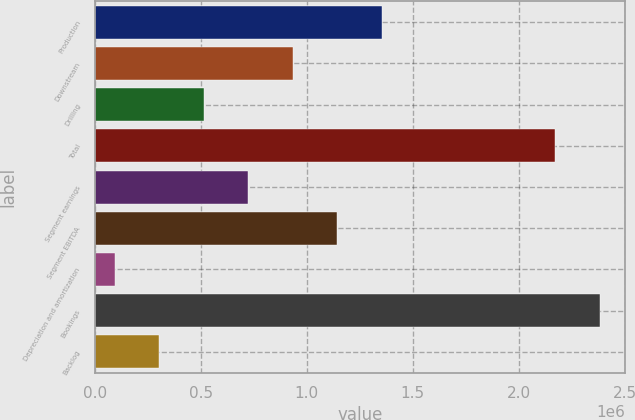<chart> <loc_0><loc_0><loc_500><loc_500><bar_chart><fcel>Production<fcel>Downstream<fcel>Drilling<fcel>Total<fcel>Segment earnings<fcel>Segment EBITDA<fcel>Depreciation and amortization<fcel>Bookings<fcel>Backlog<nl><fcel>1.35386e+06<fcel>934263<fcel>514670<fcel>2.1726e+06<fcel>724466<fcel>1.14406e+06<fcel>95077<fcel>2.3824e+06<fcel>304874<nl></chart> 